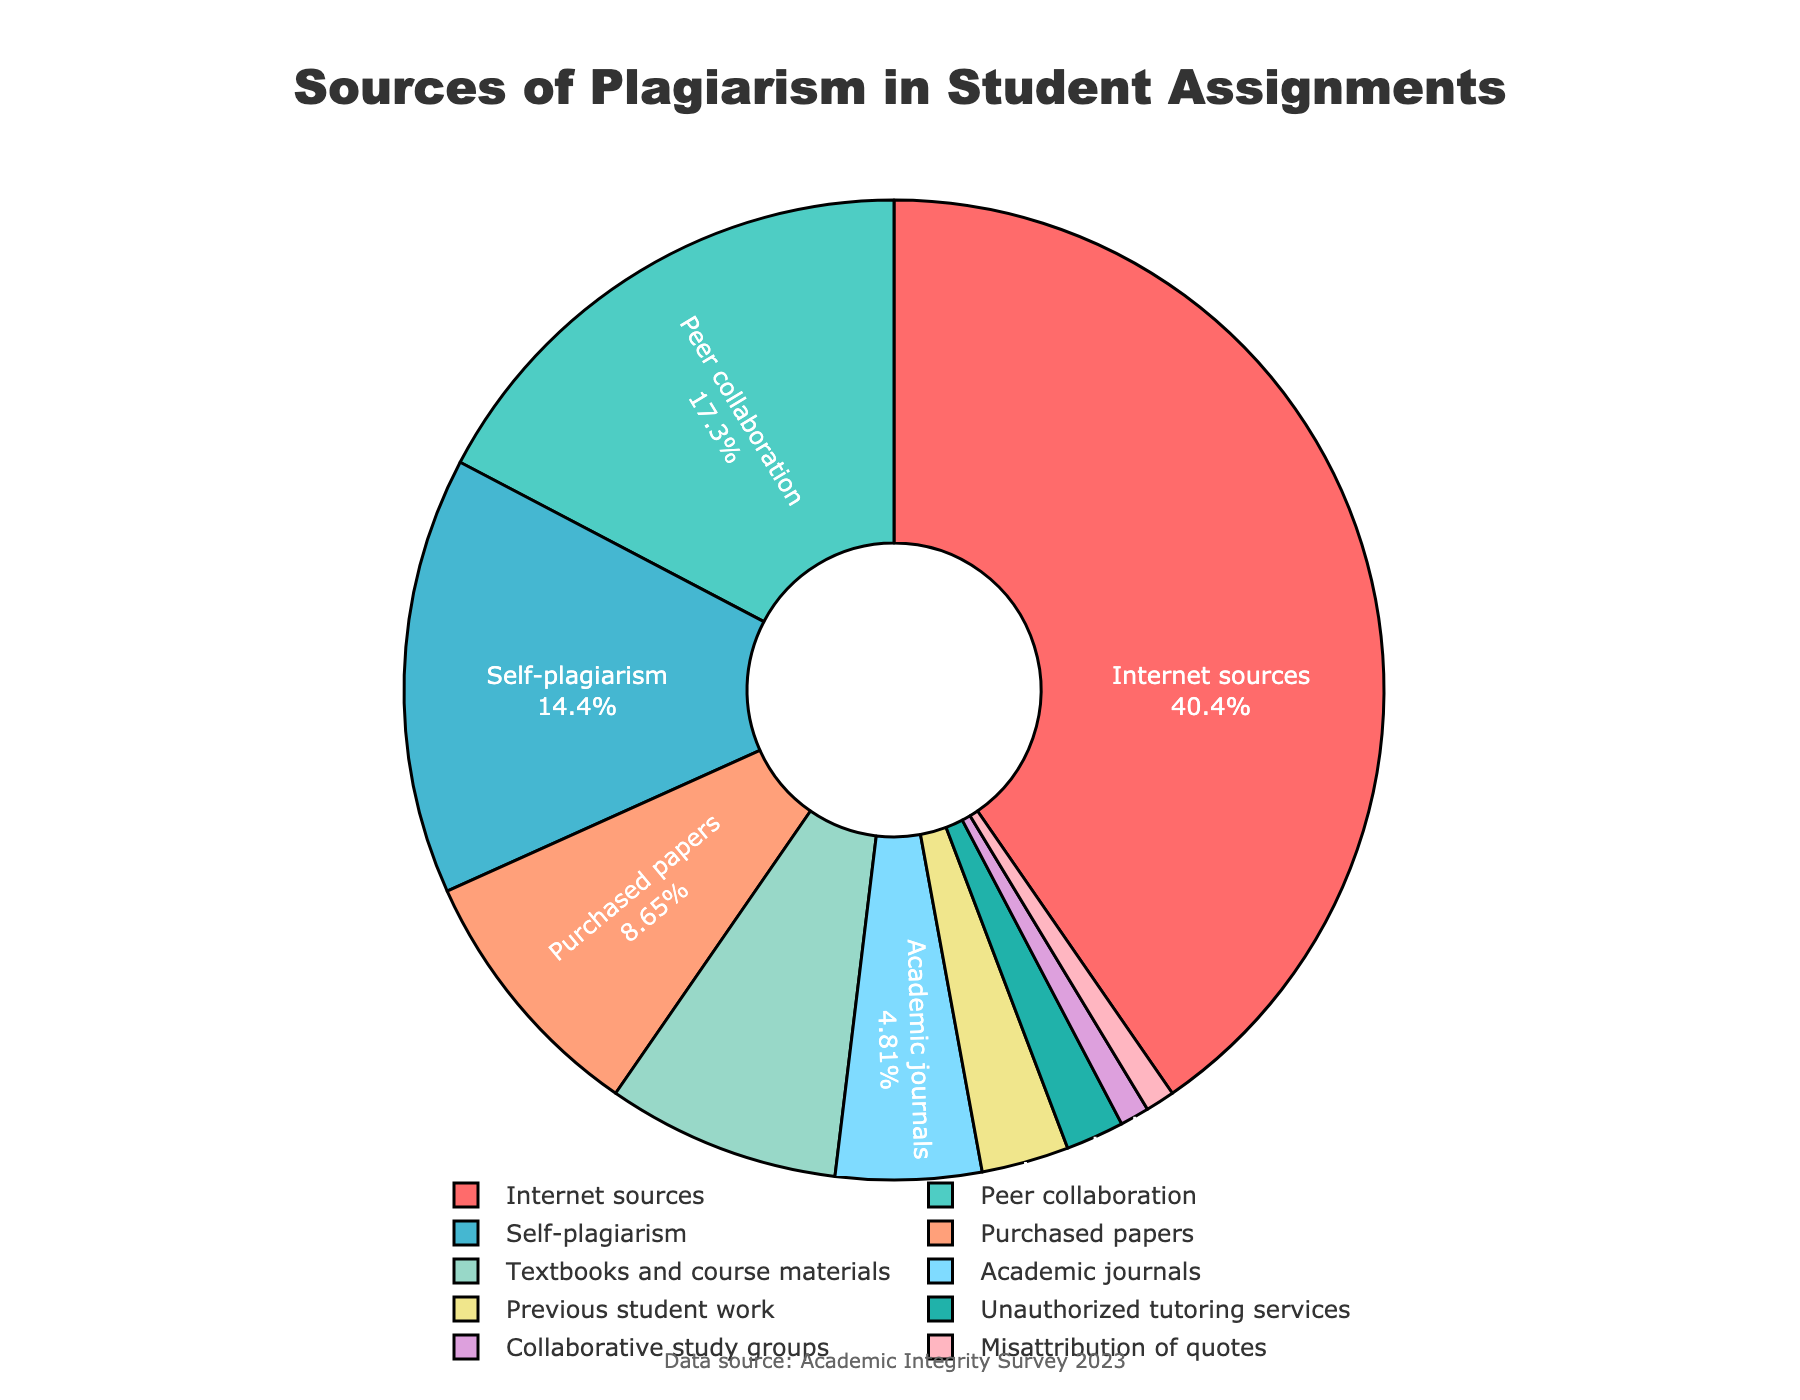Which source accounts for the highest percentage of plagiarism in student assignments? The slice representing "Internet sources" is the largest, and the label indicates it has a percentage of 42%.
Answer: Internet sources (42%) What is the combined percentage of plagiarism from peer collaboration and self-plagiarism? Peer collaboration is 18% and self-plagiarism is 15%. Adding these together: 18% + 15% = 33%.
Answer: 33% Which sources account for less than 5% each in reported plagiarism cases? The labels for "Academic journals," "Previous student work," "Unauthorized tutoring services," "Collaborative study groups," and "Misattribution of quotes" show percentages of 5%, 3%, 2%, 1%, and 1%, respectively.
Answer: Academic journals, Previous student work, Unauthorized tutoring services, Collaborative study groups, Misattribution of quotes Are textbooks and course materials more or less significant sources of plagiarism compared to purchased papers? Textbooks and course materials account for 8% while purchased papers account for 9%, making textbooks and course materials a slightly less significant source.
Answer: Less What proportion of plagiarism is accounted for by unauthorized tutoring services and collaborative study groups combined? Unauthorized tutoring services account for 2% and collaborative study groups account for 1%. Adding these together: 2% + 1% = 3%.
Answer: 3% Of the sources listed, which one has the smallest contribution to overall plagiarism? The slices for "Collaborative study groups" and "Misattribution of quotes" are the smallest and both have labels indicating 1%.
Answer: Collaborative study groups, Misattribution of quotes (1%) How much larger is the percentage of plagiarism from the Internet compared to peer collaboration? The percentage for internet sources is 42% and for peer collaboration is 18%. The difference is 42% - 18% = 24%.
Answer: 24% Which two sources have the closest percentages? Peer collaboration and self-plagiarism have percentages of 18% and 15%, respectively; the difference is 3%.
Answer: Peer collaboration and self-plagiarism What is the difference in percentage points between plagiarism from textbooks/course materials and from previous student work? Textbooks and course materials account for 8% and previous student work 3%. The difference is 8% - 3% = 5%.
Answer: 5% Do internet sources and peer collaboration together account for more than half of the plagiarism cases? Internet sources account for 42% and peer collaboration accounts for 18%. Combined, they account for 42% + 18% = 60%. Since 60% is more than 50%, they account for more than half.
Answer: Yes, 60% 